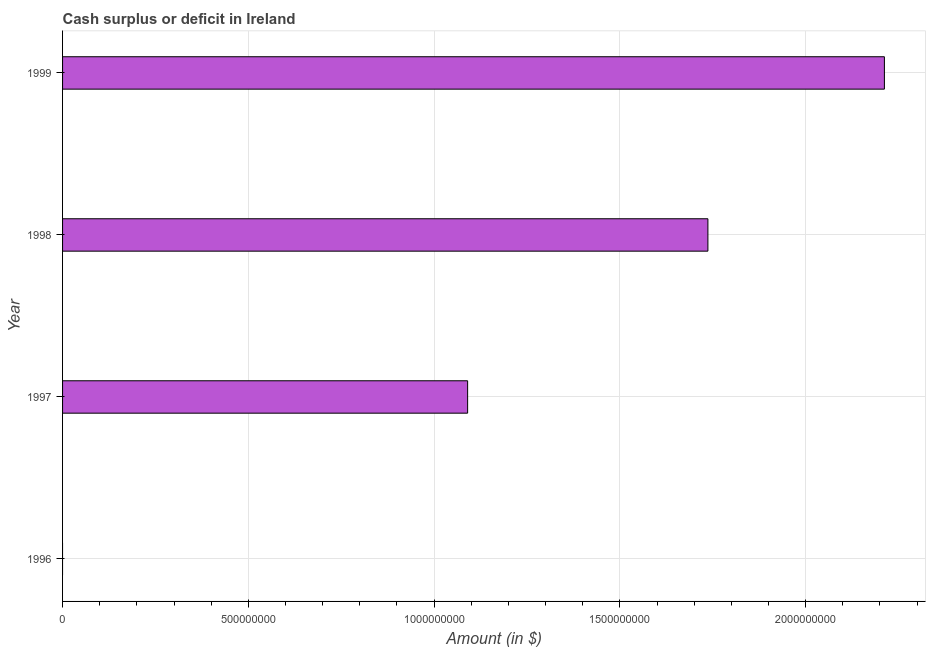Does the graph contain any zero values?
Your answer should be very brief. Yes. Does the graph contain grids?
Offer a terse response. Yes. What is the title of the graph?
Your answer should be very brief. Cash surplus or deficit in Ireland. What is the label or title of the X-axis?
Provide a short and direct response. Amount (in $). What is the label or title of the Y-axis?
Keep it short and to the point. Year. What is the cash surplus or deficit in 1997?
Make the answer very short. 1.09e+09. Across all years, what is the maximum cash surplus or deficit?
Your response must be concise. 2.21e+09. Across all years, what is the minimum cash surplus or deficit?
Provide a short and direct response. 0. In which year was the cash surplus or deficit maximum?
Offer a terse response. 1999. What is the sum of the cash surplus or deficit?
Give a very brief answer. 5.04e+09. What is the difference between the cash surplus or deficit in 1997 and 1998?
Your response must be concise. -6.47e+08. What is the average cash surplus or deficit per year?
Ensure brevity in your answer.  1.26e+09. What is the median cash surplus or deficit?
Provide a succinct answer. 1.41e+09. In how many years, is the cash surplus or deficit greater than 1600000000 $?
Ensure brevity in your answer.  2. Is the cash surplus or deficit in 1998 less than that in 1999?
Offer a terse response. Yes. Is the difference between the cash surplus or deficit in 1998 and 1999 greater than the difference between any two years?
Your response must be concise. No. What is the difference between the highest and the second highest cash surplus or deficit?
Your response must be concise. 4.75e+08. Is the sum of the cash surplus or deficit in 1997 and 1998 greater than the maximum cash surplus or deficit across all years?
Provide a succinct answer. Yes. What is the difference between the highest and the lowest cash surplus or deficit?
Make the answer very short. 2.21e+09. What is the Amount (in $) in 1997?
Offer a very short reply. 1.09e+09. What is the Amount (in $) of 1998?
Make the answer very short. 1.74e+09. What is the Amount (in $) in 1999?
Give a very brief answer. 2.21e+09. What is the difference between the Amount (in $) in 1997 and 1998?
Offer a very short reply. -6.47e+08. What is the difference between the Amount (in $) in 1997 and 1999?
Your answer should be compact. -1.12e+09. What is the difference between the Amount (in $) in 1998 and 1999?
Offer a terse response. -4.75e+08. What is the ratio of the Amount (in $) in 1997 to that in 1998?
Give a very brief answer. 0.63. What is the ratio of the Amount (in $) in 1997 to that in 1999?
Give a very brief answer. 0.49. What is the ratio of the Amount (in $) in 1998 to that in 1999?
Provide a succinct answer. 0.79. 